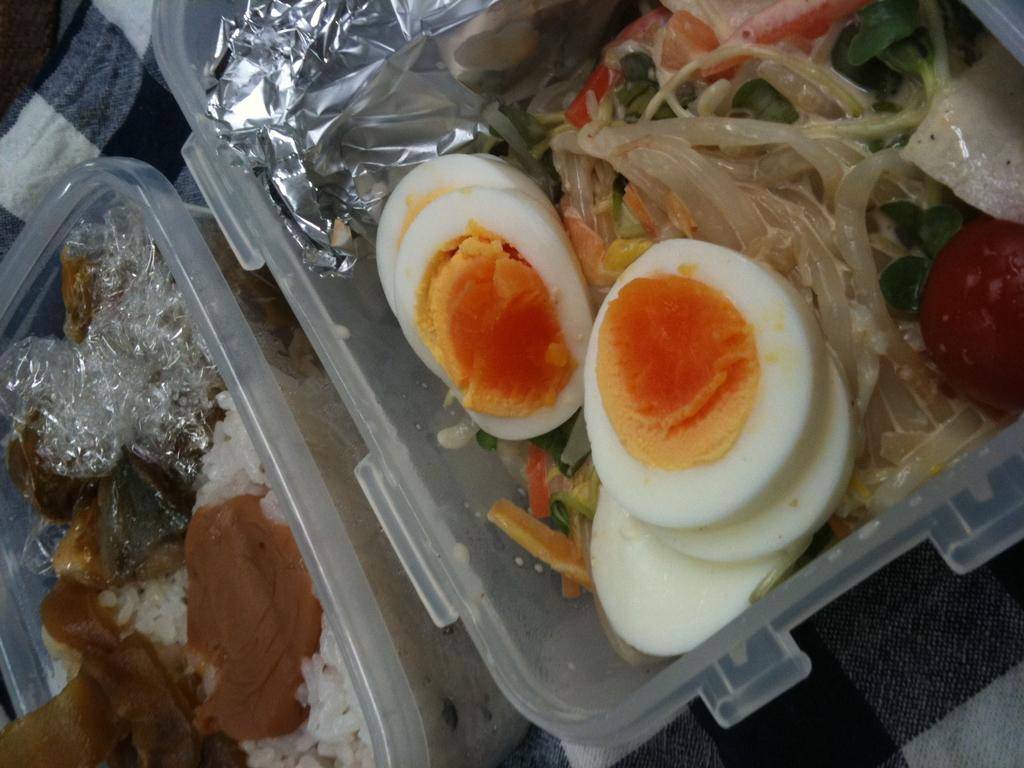Could you give a brief overview of what you see in this image? In this image I can see there are egg pieces and other food items in a plastic box. 